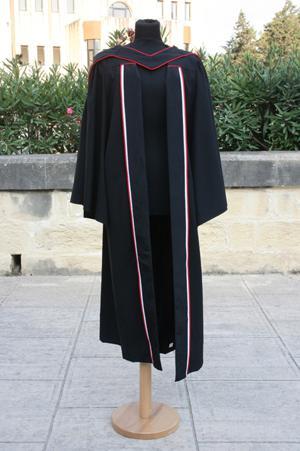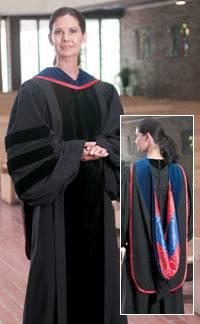The first image is the image on the left, the second image is the image on the right. For the images displayed, is the sentence "The graduation attire in one of the images is draped over a mannequin." factually correct? Answer yes or no. Yes. The first image is the image on the left, the second image is the image on the right. Examine the images to the left and right. Is the description "Each image shows a real person modeling graduation attire, with one image showing a front view and the other image showing a rear view." accurate? Answer yes or no. No. 